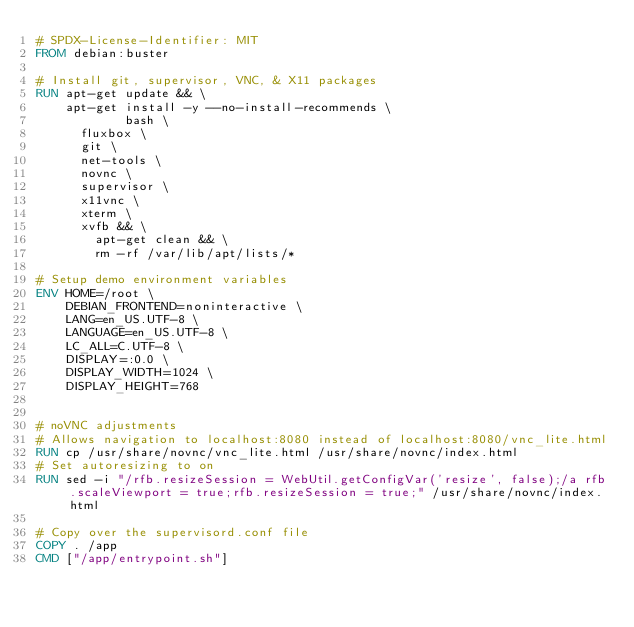<code> <loc_0><loc_0><loc_500><loc_500><_Dockerfile_># SPDX-License-Identifier: MIT
FROM debian:buster

# Install git, supervisor, VNC, & X11 packages
RUN apt-get update && \
	apt-get install -y --no-install-recommends \
			bash \
      fluxbox \
      git \
      net-tools \
      novnc \
      supervisor \
      x11vnc \
      xterm \
      xvfb && \
		apt-get clean && \
		rm -rf /var/lib/apt/lists/*

# Setup demo environment variables
ENV HOME=/root \
    DEBIAN_FRONTEND=noninteractive \
    LANG=en_US.UTF-8 \
    LANGUAGE=en_US.UTF-8 \
    LC_ALL=C.UTF-8 \
    DISPLAY=:0.0 \
    DISPLAY_WIDTH=1024 \
    DISPLAY_HEIGHT=768


# noVNC adjustments
# Allows navigation to localhost:8080 instead of localhost:8080/vnc_lite.html
RUN cp /usr/share/novnc/vnc_lite.html /usr/share/novnc/index.html
# Set autoresizing to on
RUN sed -i "/rfb.resizeSession = WebUtil.getConfigVar('resize', false);/a rfb.scaleViewport = true;rfb.resizeSession = true;" /usr/share/novnc/index.html

# Copy over the supervisord.conf file
COPY . /app
CMD ["/app/entrypoint.sh"]

</code> 